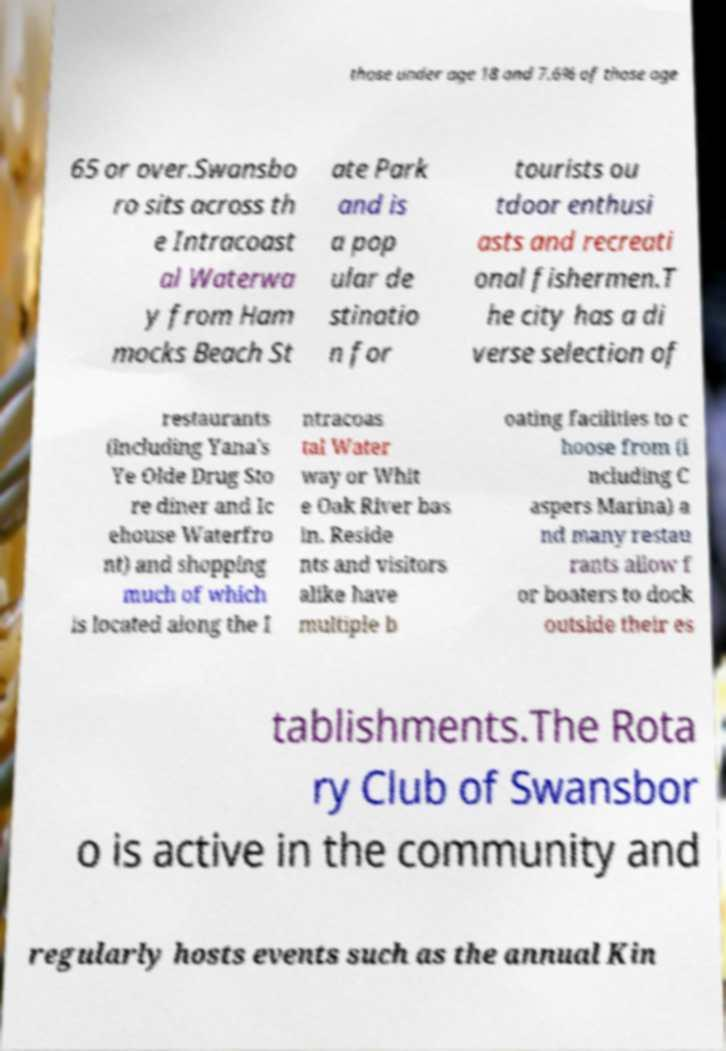I need the written content from this picture converted into text. Can you do that? those under age 18 and 7.6% of those age 65 or over.Swansbo ro sits across th e Intracoast al Waterwa y from Ham mocks Beach St ate Park and is a pop ular de stinatio n for tourists ou tdoor enthusi asts and recreati onal fishermen.T he city has a di verse selection of restaurants (including Yana's Ye Olde Drug Sto re diner and Ic ehouse Waterfro nt) and shopping much of which is located along the I ntracoas tal Water way or Whit e Oak River bas in. Reside nts and visitors alike have multiple b oating facilities to c hoose from (i ncluding C aspers Marina) a nd many restau rants allow f or boaters to dock outside their es tablishments.The Rota ry Club of Swansbor o is active in the community and regularly hosts events such as the annual Kin 